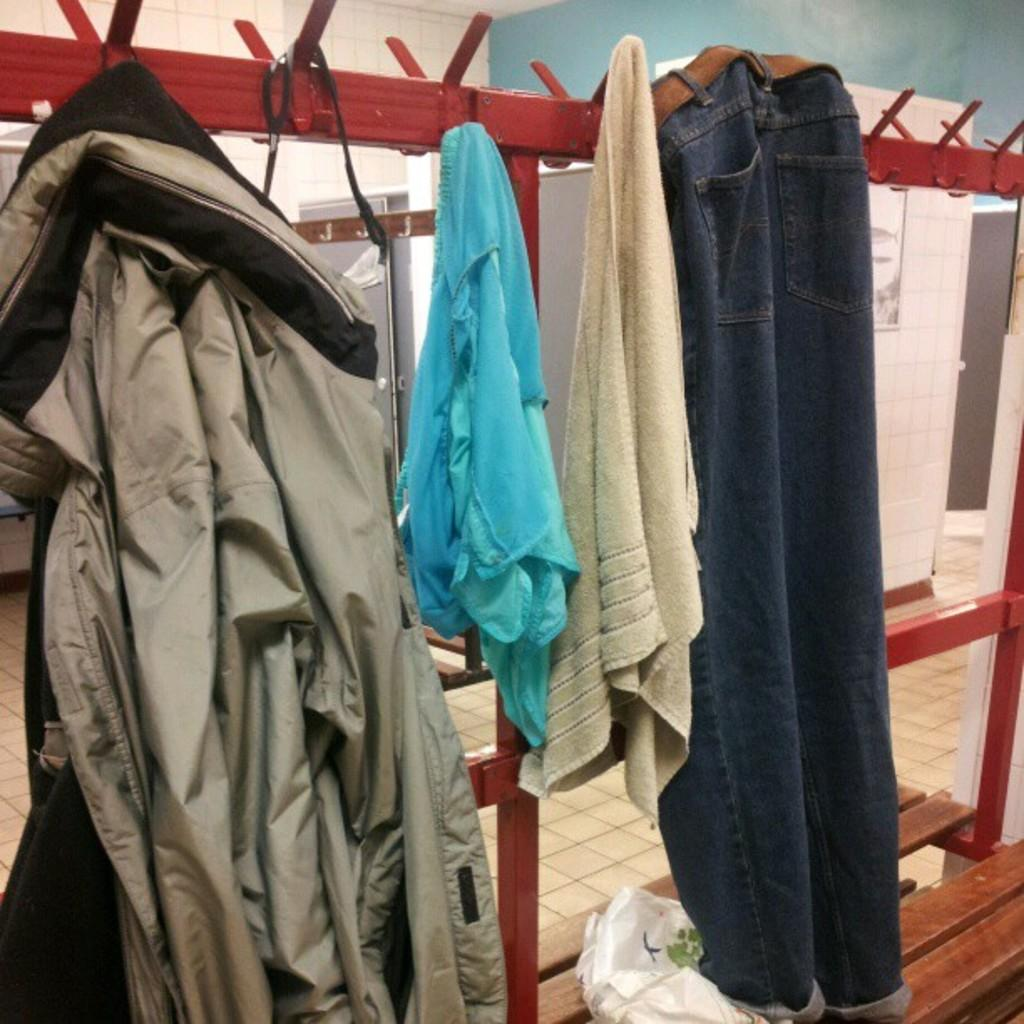What can be seen in the image related to clothing? There are clothes in the image. What type of furniture is present in the image? There is a bench in the image. What is used to protect the clothes from dust or moisture? There is a plastic cover in the image. What part of the room can be seen in the image? The floor is visible in the image. What is used to hang clothes in the image? There is a hanger in the image. What type of structure surrounds the room? There are walls in the image. What type of decorative item is present in the image? There is a frame in the image. How does the pail contribute to the operation of the room in the image? There is no pail present in the image, so it cannot contribute to any operation in the room. What type of action is being performed on the frame in the image? There is no action being performed on the frame in the image; it is simply a decorative item. 